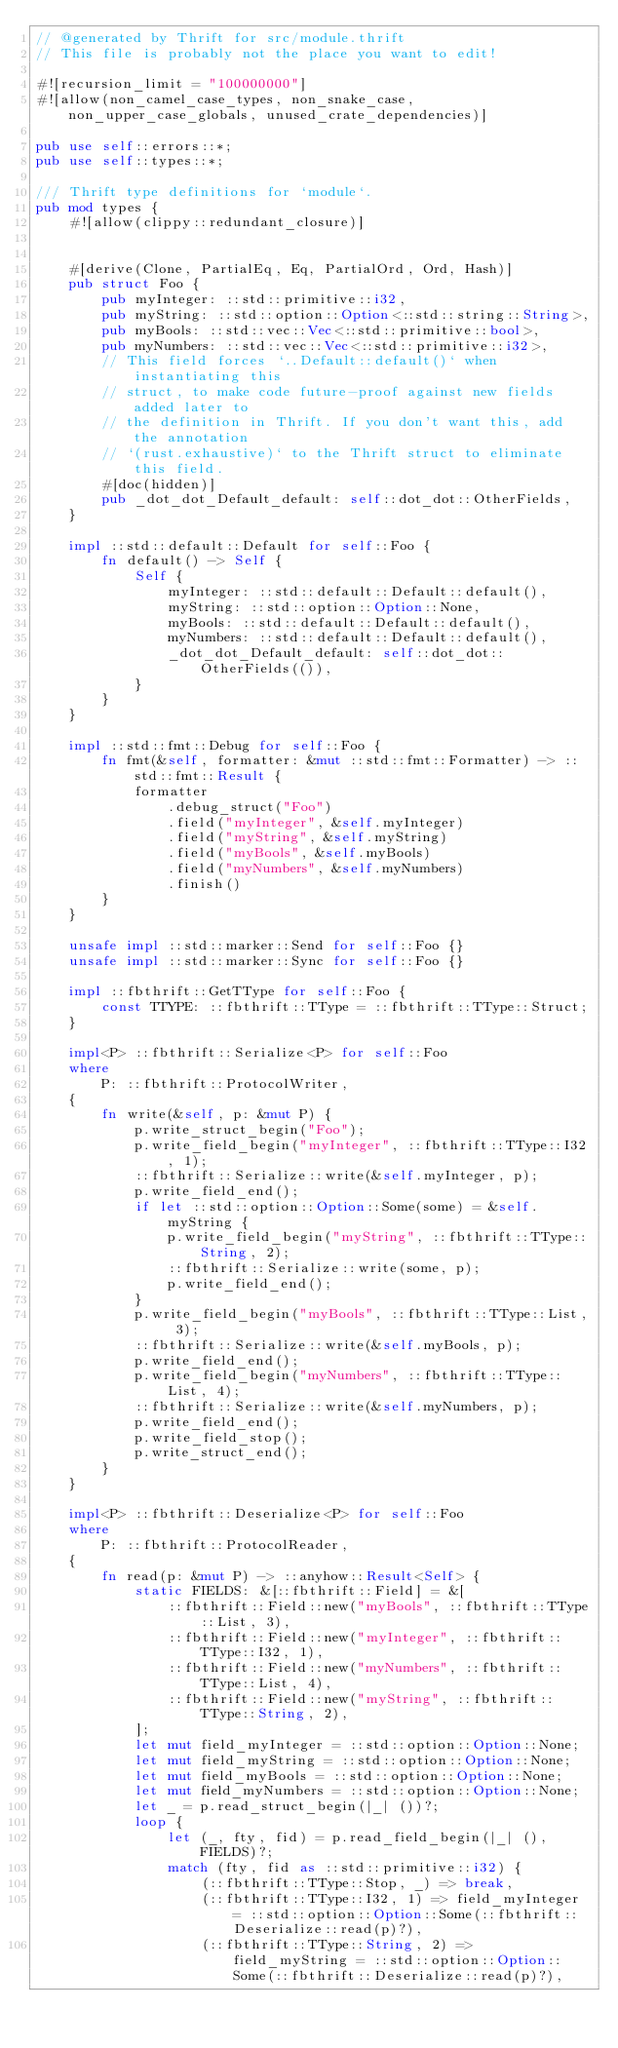<code> <loc_0><loc_0><loc_500><loc_500><_Rust_>// @generated by Thrift for src/module.thrift
// This file is probably not the place you want to edit!

#![recursion_limit = "100000000"]
#![allow(non_camel_case_types, non_snake_case, non_upper_case_globals, unused_crate_dependencies)]

pub use self::errors::*;
pub use self::types::*;

/// Thrift type definitions for `module`.
pub mod types {
    #![allow(clippy::redundant_closure)]


    #[derive(Clone, PartialEq, Eq, PartialOrd, Ord, Hash)]
    pub struct Foo {
        pub myInteger: ::std::primitive::i32,
        pub myString: ::std::option::Option<::std::string::String>,
        pub myBools: ::std::vec::Vec<::std::primitive::bool>,
        pub myNumbers: ::std::vec::Vec<::std::primitive::i32>,
        // This field forces `..Default::default()` when instantiating this
        // struct, to make code future-proof against new fields added later to
        // the definition in Thrift. If you don't want this, add the annotation
        // `(rust.exhaustive)` to the Thrift struct to eliminate this field.
        #[doc(hidden)]
        pub _dot_dot_Default_default: self::dot_dot::OtherFields,
    }

    impl ::std::default::Default for self::Foo {
        fn default() -> Self {
            Self {
                myInteger: ::std::default::Default::default(),
                myString: ::std::option::Option::None,
                myBools: ::std::default::Default::default(),
                myNumbers: ::std::default::Default::default(),
                _dot_dot_Default_default: self::dot_dot::OtherFields(()),
            }
        }
    }

    impl ::std::fmt::Debug for self::Foo {
        fn fmt(&self, formatter: &mut ::std::fmt::Formatter) -> ::std::fmt::Result {
            formatter
                .debug_struct("Foo")
                .field("myInteger", &self.myInteger)
                .field("myString", &self.myString)
                .field("myBools", &self.myBools)
                .field("myNumbers", &self.myNumbers)
                .finish()
        }
    }

    unsafe impl ::std::marker::Send for self::Foo {}
    unsafe impl ::std::marker::Sync for self::Foo {}

    impl ::fbthrift::GetTType for self::Foo {
        const TTYPE: ::fbthrift::TType = ::fbthrift::TType::Struct;
    }

    impl<P> ::fbthrift::Serialize<P> for self::Foo
    where
        P: ::fbthrift::ProtocolWriter,
    {
        fn write(&self, p: &mut P) {
            p.write_struct_begin("Foo");
            p.write_field_begin("myInteger", ::fbthrift::TType::I32, 1);
            ::fbthrift::Serialize::write(&self.myInteger, p);
            p.write_field_end();
            if let ::std::option::Option::Some(some) = &self.myString {
                p.write_field_begin("myString", ::fbthrift::TType::String, 2);
                ::fbthrift::Serialize::write(some, p);
                p.write_field_end();
            }
            p.write_field_begin("myBools", ::fbthrift::TType::List, 3);
            ::fbthrift::Serialize::write(&self.myBools, p);
            p.write_field_end();
            p.write_field_begin("myNumbers", ::fbthrift::TType::List, 4);
            ::fbthrift::Serialize::write(&self.myNumbers, p);
            p.write_field_end();
            p.write_field_stop();
            p.write_struct_end();
        }
    }

    impl<P> ::fbthrift::Deserialize<P> for self::Foo
    where
        P: ::fbthrift::ProtocolReader,
    {
        fn read(p: &mut P) -> ::anyhow::Result<Self> {
            static FIELDS: &[::fbthrift::Field] = &[
                ::fbthrift::Field::new("myBools", ::fbthrift::TType::List, 3),
                ::fbthrift::Field::new("myInteger", ::fbthrift::TType::I32, 1),
                ::fbthrift::Field::new("myNumbers", ::fbthrift::TType::List, 4),
                ::fbthrift::Field::new("myString", ::fbthrift::TType::String, 2),
            ];
            let mut field_myInteger = ::std::option::Option::None;
            let mut field_myString = ::std::option::Option::None;
            let mut field_myBools = ::std::option::Option::None;
            let mut field_myNumbers = ::std::option::Option::None;
            let _ = p.read_struct_begin(|_| ())?;
            loop {
                let (_, fty, fid) = p.read_field_begin(|_| (), FIELDS)?;
                match (fty, fid as ::std::primitive::i32) {
                    (::fbthrift::TType::Stop, _) => break,
                    (::fbthrift::TType::I32, 1) => field_myInteger = ::std::option::Option::Some(::fbthrift::Deserialize::read(p)?),
                    (::fbthrift::TType::String, 2) => field_myString = ::std::option::Option::Some(::fbthrift::Deserialize::read(p)?),</code> 